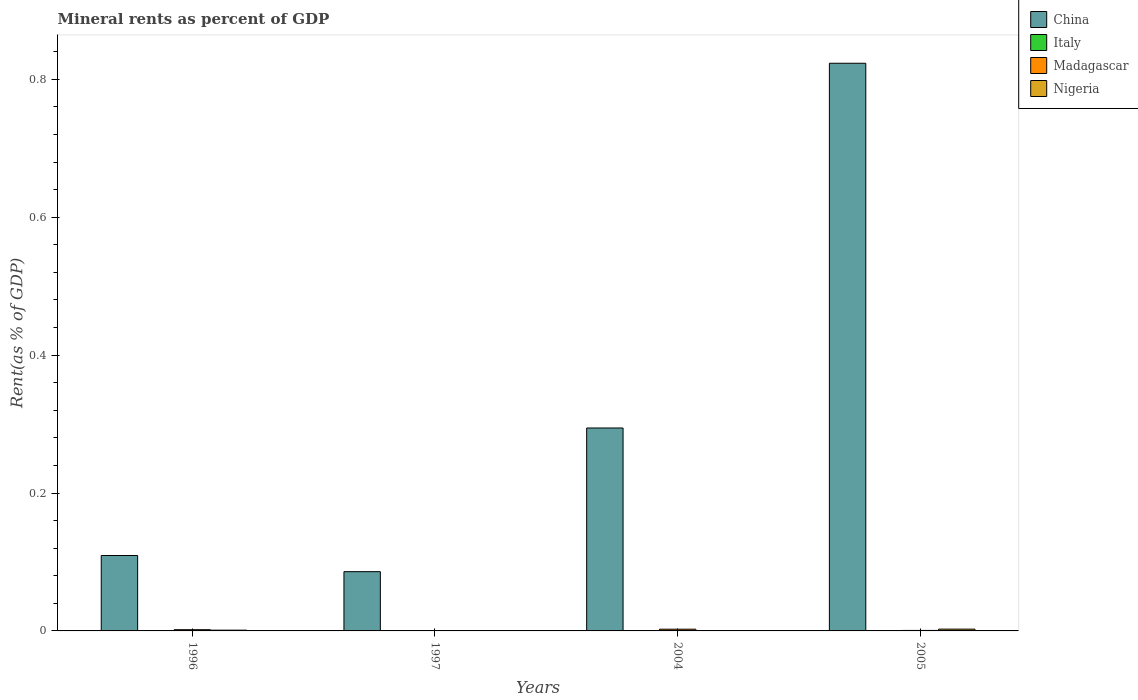How many different coloured bars are there?
Provide a succinct answer. 4. How many groups of bars are there?
Offer a terse response. 4. Are the number of bars per tick equal to the number of legend labels?
Provide a succinct answer. Yes. How many bars are there on the 3rd tick from the left?
Provide a succinct answer. 4. What is the label of the 3rd group of bars from the left?
Ensure brevity in your answer.  2004. In how many cases, is the number of bars for a given year not equal to the number of legend labels?
Provide a short and direct response. 0. What is the mineral rent in Italy in 2005?
Your response must be concise. 5.19978483060913e-5. Across all years, what is the maximum mineral rent in Nigeria?
Offer a very short reply. 0. Across all years, what is the minimum mineral rent in China?
Provide a short and direct response. 0.09. In which year was the mineral rent in Nigeria maximum?
Ensure brevity in your answer.  2005. What is the total mineral rent in Italy in the graph?
Ensure brevity in your answer.  0. What is the difference between the mineral rent in China in 1996 and that in 2005?
Keep it short and to the point. -0.71. What is the difference between the mineral rent in Italy in 1996 and the mineral rent in China in 2004?
Make the answer very short. -0.29. What is the average mineral rent in Italy per year?
Your answer should be very brief. 5.76564031157783e-5. In the year 1997, what is the difference between the mineral rent in Madagascar and mineral rent in Nigeria?
Your answer should be compact. -0. In how many years, is the mineral rent in Madagascar greater than 0.7600000000000001 %?
Your answer should be compact. 0. What is the ratio of the mineral rent in Italy in 1997 to that in 2004?
Make the answer very short. 0.28. Is the mineral rent in Italy in 2004 less than that in 2005?
Your answer should be compact. Yes. Is the difference between the mineral rent in Madagascar in 1996 and 2005 greater than the difference between the mineral rent in Nigeria in 1996 and 2005?
Keep it short and to the point. Yes. What is the difference between the highest and the second highest mineral rent in Madagascar?
Provide a short and direct response. 0. What is the difference between the highest and the lowest mineral rent in China?
Give a very brief answer. 0.74. Is it the case that in every year, the sum of the mineral rent in Italy and mineral rent in Madagascar is greater than the sum of mineral rent in China and mineral rent in Nigeria?
Provide a short and direct response. No. What does the 4th bar from the left in 2004 represents?
Give a very brief answer. Nigeria. What does the 2nd bar from the right in 1996 represents?
Your answer should be very brief. Madagascar. Is it the case that in every year, the sum of the mineral rent in China and mineral rent in Madagascar is greater than the mineral rent in Nigeria?
Give a very brief answer. Yes. Are all the bars in the graph horizontal?
Your response must be concise. No. How many years are there in the graph?
Your response must be concise. 4. Where does the legend appear in the graph?
Provide a short and direct response. Top right. How many legend labels are there?
Your response must be concise. 4. How are the legend labels stacked?
Provide a short and direct response. Vertical. What is the title of the graph?
Give a very brief answer. Mineral rents as percent of GDP. Does "Czech Republic" appear as one of the legend labels in the graph?
Give a very brief answer. No. What is the label or title of the Y-axis?
Your answer should be compact. Rent(as % of GDP). What is the Rent(as % of GDP) in China in 1996?
Your answer should be compact. 0.11. What is the Rent(as % of GDP) of Italy in 1996?
Keep it short and to the point. 0. What is the Rent(as % of GDP) in Madagascar in 1996?
Offer a terse response. 0. What is the Rent(as % of GDP) of Nigeria in 1996?
Provide a succinct answer. 0. What is the Rent(as % of GDP) of China in 1997?
Offer a terse response. 0.09. What is the Rent(as % of GDP) of Italy in 1997?
Ensure brevity in your answer.  1.39725048171068e-5. What is the Rent(as % of GDP) in Madagascar in 1997?
Provide a short and direct response. 2.73933641569533e-5. What is the Rent(as % of GDP) in Nigeria in 1997?
Give a very brief answer. 0. What is the Rent(as % of GDP) of China in 2004?
Your response must be concise. 0.29. What is the Rent(as % of GDP) in Italy in 2004?
Keep it short and to the point. 5.04562722027911e-5. What is the Rent(as % of GDP) of Madagascar in 2004?
Make the answer very short. 0. What is the Rent(as % of GDP) in Nigeria in 2004?
Your response must be concise. 9.366364684286959e-5. What is the Rent(as % of GDP) in China in 2005?
Your answer should be very brief. 0.82. What is the Rent(as % of GDP) of Italy in 2005?
Give a very brief answer. 5.19978483060913e-5. What is the Rent(as % of GDP) of Madagascar in 2005?
Give a very brief answer. 0. What is the Rent(as % of GDP) in Nigeria in 2005?
Provide a succinct answer. 0. Across all years, what is the maximum Rent(as % of GDP) of China?
Give a very brief answer. 0.82. Across all years, what is the maximum Rent(as % of GDP) in Italy?
Ensure brevity in your answer.  0. Across all years, what is the maximum Rent(as % of GDP) of Madagascar?
Offer a terse response. 0. Across all years, what is the maximum Rent(as % of GDP) in Nigeria?
Provide a succinct answer. 0. Across all years, what is the minimum Rent(as % of GDP) of China?
Make the answer very short. 0.09. Across all years, what is the minimum Rent(as % of GDP) of Italy?
Provide a short and direct response. 1.39725048171068e-5. Across all years, what is the minimum Rent(as % of GDP) of Madagascar?
Offer a terse response. 2.73933641569533e-5. Across all years, what is the minimum Rent(as % of GDP) in Nigeria?
Provide a short and direct response. 9.366364684286959e-5. What is the total Rent(as % of GDP) in China in the graph?
Keep it short and to the point. 1.31. What is the total Rent(as % of GDP) of Italy in the graph?
Offer a terse response. 0. What is the total Rent(as % of GDP) in Madagascar in the graph?
Your answer should be compact. 0.01. What is the total Rent(as % of GDP) in Nigeria in the graph?
Provide a short and direct response. 0. What is the difference between the Rent(as % of GDP) in China in 1996 and that in 1997?
Keep it short and to the point. 0.02. What is the difference between the Rent(as % of GDP) in Italy in 1996 and that in 1997?
Keep it short and to the point. 0. What is the difference between the Rent(as % of GDP) of Madagascar in 1996 and that in 1997?
Ensure brevity in your answer.  0. What is the difference between the Rent(as % of GDP) of China in 1996 and that in 2004?
Offer a terse response. -0.18. What is the difference between the Rent(as % of GDP) in Madagascar in 1996 and that in 2004?
Offer a terse response. -0. What is the difference between the Rent(as % of GDP) of China in 1996 and that in 2005?
Provide a short and direct response. -0.71. What is the difference between the Rent(as % of GDP) of Italy in 1996 and that in 2005?
Keep it short and to the point. 0. What is the difference between the Rent(as % of GDP) in Madagascar in 1996 and that in 2005?
Provide a succinct answer. 0. What is the difference between the Rent(as % of GDP) of Nigeria in 1996 and that in 2005?
Keep it short and to the point. -0. What is the difference between the Rent(as % of GDP) of China in 1997 and that in 2004?
Your response must be concise. -0.21. What is the difference between the Rent(as % of GDP) of Italy in 1997 and that in 2004?
Your response must be concise. -0. What is the difference between the Rent(as % of GDP) of Madagascar in 1997 and that in 2004?
Provide a short and direct response. -0. What is the difference between the Rent(as % of GDP) in Nigeria in 1997 and that in 2004?
Make the answer very short. 0. What is the difference between the Rent(as % of GDP) in China in 1997 and that in 2005?
Provide a succinct answer. -0.74. What is the difference between the Rent(as % of GDP) of Madagascar in 1997 and that in 2005?
Ensure brevity in your answer.  -0. What is the difference between the Rent(as % of GDP) of Nigeria in 1997 and that in 2005?
Offer a very short reply. -0. What is the difference between the Rent(as % of GDP) in China in 2004 and that in 2005?
Make the answer very short. -0.53. What is the difference between the Rent(as % of GDP) of Madagascar in 2004 and that in 2005?
Provide a succinct answer. 0. What is the difference between the Rent(as % of GDP) in Nigeria in 2004 and that in 2005?
Offer a terse response. -0. What is the difference between the Rent(as % of GDP) of China in 1996 and the Rent(as % of GDP) of Italy in 1997?
Offer a terse response. 0.11. What is the difference between the Rent(as % of GDP) in China in 1996 and the Rent(as % of GDP) in Madagascar in 1997?
Give a very brief answer. 0.11. What is the difference between the Rent(as % of GDP) of China in 1996 and the Rent(as % of GDP) of Nigeria in 1997?
Offer a terse response. 0.11. What is the difference between the Rent(as % of GDP) of Italy in 1996 and the Rent(as % of GDP) of Nigeria in 1997?
Your answer should be very brief. -0. What is the difference between the Rent(as % of GDP) in Madagascar in 1996 and the Rent(as % of GDP) in Nigeria in 1997?
Your answer should be very brief. 0. What is the difference between the Rent(as % of GDP) of China in 1996 and the Rent(as % of GDP) of Italy in 2004?
Provide a short and direct response. 0.11. What is the difference between the Rent(as % of GDP) in China in 1996 and the Rent(as % of GDP) in Madagascar in 2004?
Offer a very short reply. 0.11. What is the difference between the Rent(as % of GDP) of China in 1996 and the Rent(as % of GDP) of Nigeria in 2004?
Offer a terse response. 0.11. What is the difference between the Rent(as % of GDP) in Italy in 1996 and the Rent(as % of GDP) in Madagascar in 2004?
Ensure brevity in your answer.  -0. What is the difference between the Rent(as % of GDP) in Madagascar in 1996 and the Rent(as % of GDP) in Nigeria in 2004?
Ensure brevity in your answer.  0. What is the difference between the Rent(as % of GDP) of China in 1996 and the Rent(as % of GDP) of Italy in 2005?
Make the answer very short. 0.11. What is the difference between the Rent(as % of GDP) in China in 1996 and the Rent(as % of GDP) in Madagascar in 2005?
Keep it short and to the point. 0.11. What is the difference between the Rent(as % of GDP) in China in 1996 and the Rent(as % of GDP) in Nigeria in 2005?
Offer a very short reply. 0.11. What is the difference between the Rent(as % of GDP) in Italy in 1996 and the Rent(as % of GDP) in Madagascar in 2005?
Make the answer very short. -0. What is the difference between the Rent(as % of GDP) of Italy in 1996 and the Rent(as % of GDP) of Nigeria in 2005?
Offer a terse response. -0. What is the difference between the Rent(as % of GDP) in Madagascar in 1996 and the Rent(as % of GDP) in Nigeria in 2005?
Keep it short and to the point. -0. What is the difference between the Rent(as % of GDP) of China in 1997 and the Rent(as % of GDP) of Italy in 2004?
Your answer should be compact. 0.09. What is the difference between the Rent(as % of GDP) in China in 1997 and the Rent(as % of GDP) in Madagascar in 2004?
Give a very brief answer. 0.08. What is the difference between the Rent(as % of GDP) in China in 1997 and the Rent(as % of GDP) in Nigeria in 2004?
Give a very brief answer. 0.09. What is the difference between the Rent(as % of GDP) of Italy in 1997 and the Rent(as % of GDP) of Madagascar in 2004?
Provide a succinct answer. -0. What is the difference between the Rent(as % of GDP) of Italy in 1997 and the Rent(as % of GDP) of Nigeria in 2004?
Provide a short and direct response. -0. What is the difference between the Rent(as % of GDP) in Madagascar in 1997 and the Rent(as % of GDP) in Nigeria in 2004?
Ensure brevity in your answer.  -0. What is the difference between the Rent(as % of GDP) of China in 1997 and the Rent(as % of GDP) of Italy in 2005?
Your response must be concise. 0.09. What is the difference between the Rent(as % of GDP) in China in 1997 and the Rent(as % of GDP) in Madagascar in 2005?
Offer a terse response. 0.09. What is the difference between the Rent(as % of GDP) in China in 1997 and the Rent(as % of GDP) in Nigeria in 2005?
Give a very brief answer. 0.08. What is the difference between the Rent(as % of GDP) of Italy in 1997 and the Rent(as % of GDP) of Madagascar in 2005?
Your answer should be very brief. -0. What is the difference between the Rent(as % of GDP) of Italy in 1997 and the Rent(as % of GDP) of Nigeria in 2005?
Your response must be concise. -0. What is the difference between the Rent(as % of GDP) of Madagascar in 1997 and the Rent(as % of GDP) of Nigeria in 2005?
Offer a terse response. -0. What is the difference between the Rent(as % of GDP) of China in 2004 and the Rent(as % of GDP) of Italy in 2005?
Provide a short and direct response. 0.29. What is the difference between the Rent(as % of GDP) in China in 2004 and the Rent(as % of GDP) in Madagascar in 2005?
Your answer should be compact. 0.29. What is the difference between the Rent(as % of GDP) of China in 2004 and the Rent(as % of GDP) of Nigeria in 2005?
Your answer should be very brief. 0.29. What is the difference between the Rent(as % of GDP) of Italy in 2004 and the Rent(as % of GDP) of Madagascar in 2005?
Make the answer very short. -0. What is the difference between the Rent(as % of GDP) of Italy in 2004 and the Rent(as % of GDP) of Nigeria in 2005?
Keep it short and to the point. -0. What is the difference between the Rent(as % of GDP) of Madagascar in 2004 and the Rent(as % of GDP) of Nigeria in 2005?
Provide a short and direct response. -0. What is the average Rent(as % of GDP) of China per year?
Your answer should be very brief. 0.33. What is the average Rent(as % of GDP) of Italy per year?
Offer a terse response. 0. What is the average Rent(as % of GDP) of Madagascar per year?
Your answer should be compact. 0. What is the average Rent(as % of GDP) in Nigeria per year?
Offer a terse response. 0. In the year 1996, what is the difference between the Rent(as % of GDP) in China and Rent(as % of GDP) in Italy?
Your answer should be very brief. 0.11. In the year 1996, what is the difference between the Rent(as % of GDP) in China and Rent(as % of GDP) in Madagascar?
Your answer should be compact. 0.11. In the year 1996, what is the difference between the Rent(as % of GDP) in China and Rent(as % of GDP) in Nigeria?
Make the answer very short. 0.11. In the year 1996, what is the difference between the Rent(as % of GDP) in Italy and Rent(as % of GDP) in Madagascar?
Your answer should be compact. -0. In the year 1996, what is the difference between the Rent(as % of GDP) in Italy and Rent(as % of GDP) in Nigeria?
Offer a very short reply. -0. In the year 1996, what is the difference between the Rent(as % of GDP) of Madagascar and Rent(as % of GDP) of Nigeria?
Your answer should be compact. 0. In the year 1997, what is the difference between the Rent(as % of GDP) of China and Rent(as % of GDP) of Italy?
Offer a very short reply. 0.09. In the year 1997, what is the difference between the Rent(as % of GDP) in China and Rent(as % of GDP) in Madagascar?
Provide a succinct answer. 0.09. In the year 1997, what is the difference between the Rent(as % of GDP) in China and Rent(as % of GDP) in Nigeria?
Provide a succinct answer. 0.09. In the year 1997, what is the difference between the Rent(as % of GDP) of Italy and Rent(as % of GDP) of Madagascar?
Your answer should be very brief. -0. In the year 1997, what is the difference between the Rent(as % of GDP) of Italy and Rent(as % of GDP) of Nigeria?
Offer a very short reply. -0. In the year 1997, what is the difference between the Rent(as % of GDP) in Madagascar and Rent(as % of GDP) in Nigeria?
Your answer should be compact. -0. In the year 2004, what is the difference between the Rent(as % of GDP) of China and Rent(as % of GDP) of Italy?
Your response must be concise. 0.29. In the year 2004, what is the difference between the Rent(as % of GDP) of China and Rent(as % of GDP) of Madagascar?
Give a very brief answer. 0.29. In the year 2004, what is the difference between the Rent(as % of GDP) of China and Rent(as % of GDP) of Nigeria?
Give a very brief answer. 0.29. In the year 2004, what is the difference between the Rent(as % of GDP) of Italy and Rent(as % of GDP) of Madagascar?
Offer a terse response. -0. In the year 2004, what is the difference between the Rent(as % of GDP) of Madagascar and Rent(as % of GDP) of Nigeria?
Ensure brevity in your answer.  0. In the year 2005, what is the difference between the Rent(as % of GDP) of China and Rent(as % of GDP) of Italy?
Your response must be concise. 0.82. In the year 2005, what is the difference between the Rent(as % of GDP) in China and Rent(as % of GDP) in Madagascar?
Ensure brevity in your answer.  0.82. In the year 2005, what is the difference between the Rent(as % of GDP) of China and Rent(as % of GDP) of Nigeria?
Your response must be concise. 0.82. In the year 2005, what is the difference between the Rent(as % of GDP) in Italy and Rent(as % of GDP) in Madagascar?
Your answer should be compact. -0. In the year 2005, what is the difference between the Rent(as % of GDP) of Italy and Rent(as % of GDP) of Nigeria?
Your answer should be compact. -0. In the year 2005, what is the difference between the Rent(as % of GDP) of Madagascar and Rent(as % of GDP) of Nigeria?
Offer a terse response. -0. What is the ratio of the Rent(as % of GDP) of China in 1996 to that in 1997?
Your answer should be compact. 1.27. What is the ratio of the Rent(as % of GDP) in Italy in 1996 to that in 1997?
Provide a short and direct response. 8.17. What is the ratio of the Rent(as % of GDP) of Madagascar in 1996 to that in 1997?
Keep it short and to the point. 64.93. What is the ratio of the Rent(as % of GDP) of Nigeria in 1996 to that in 1997?
Give a very brief answer. 1.86. What is the ratio of the Rent(as % of GDP) of China in 1996 to that in 2004?
Offer a very short reply. 0.37. What is the ratio of the Rent(as % of GDP) in Italy in 1996 to that in 2004?
Provide a short and direct response. 2.26. What is the ratio of the Rent(as % of GDP) in Madagascar in 1996 to that in 2004?
Offer a terse response. 0.71. What is the ratio of the Rent(as % of GDP) of Nigeria in 1996 to that in 2004?
Your response must be concise. 11.63. What is the ratio of the Rent(as % of GDP) in China in 1996 to that in 2005?
Give a very brief answer. 0.13. What is the ratio of the Rent(as % of GDP) in Italy in 1996 to that in 2005?
Your answer should be compact. 2.2. What is the ratio of the Rent(as % of GDP) of Madagascar in 1996 to that in 2005?
Give a very brief answer. 2.52. What is the ratio of the Rent(as % of GDP) of Nigeria in 1996 to that in 2005?
Give a very brief answer. 0.42. What is the ratio of the Rent(as % of GDP) in China in 1997 to that in 2004?
Offer a very short reply. 0.29. What is the ratio of the Rent(as % of GDP) in Italy in 1997 to that in 2004?
Offer a terse response. 0.28. What is the ratio of the Rent(as % of GDP) in Madagascar in 1997 to that in 2004?
Provide a succinct answer. 0.01. What is the ratio of the Rent(as % of GDP) of Nigeria in 1997 to that in 2004?
Your answer should be compact. 6.27. What is the ratio of the Rent(as % of GDP) of China in 1997 to that in 2005?
Provide a short and direct response. 0.1. What is the ratio of the Rent(as % of GDP) in Italy in 1997 to that in 2005?
Make the answer very short. 0.27. What is the ratio of the Rent(as % of GDP) in Madagascar in 1997 to that in 2005?
Keep it short and to the point. 0.04. What is the ratio of the Rent(as % of GDP) of Nigeria in 1997 to that in 2005?
Offer a very short reply. 0.23. What is the ratio of the Rent(as % of GDP) of China in 2004 to that in 2005?
Provide a succinct answer. 0.36. What is the ratio of the Rent(as % of GDP) of Italy in 2004 to that in 2005?
Ensure brevity in your answer.  0.97. What is the ratio of the Rent(as % of GDP) of Madagascar in 2004 to that in 2005?
Make the answer very short. 3.56. What is the ratio of the Rent(as % of GDP) of Nigeria in 2004 to that in 2005?
Provide a short and direct response. 0.04. What is the difference between the highest and the second highest Rent(as % of GDP) in China?
Provide a short and direct response. 0.53. What is the difference between the highest and the second highest Rent(as % of GDP) of Italy?
Ensure brevity in your answer.  0. What is the difference between the highest and the second highest Rent(as % of GDP) of Madagascar?
Give a very brief answer. 0. What is the difference between the highest and the second highest Rent(as % of GDP) of Nigeria?
Offer a very short reply. 0. What is the difference between the highest and the lowest Rent(as % of GDP) in China?
Provide a succinct answer. 0.74. What is the difference between the highest and the lowest Rent(as % of GDP) of Madagascar?
Provide a succinct answer. 0. What is the difference between the highest and the lowest Rent(as % of GDP) of Nigeria?
Your answer should be very brief. 0. 